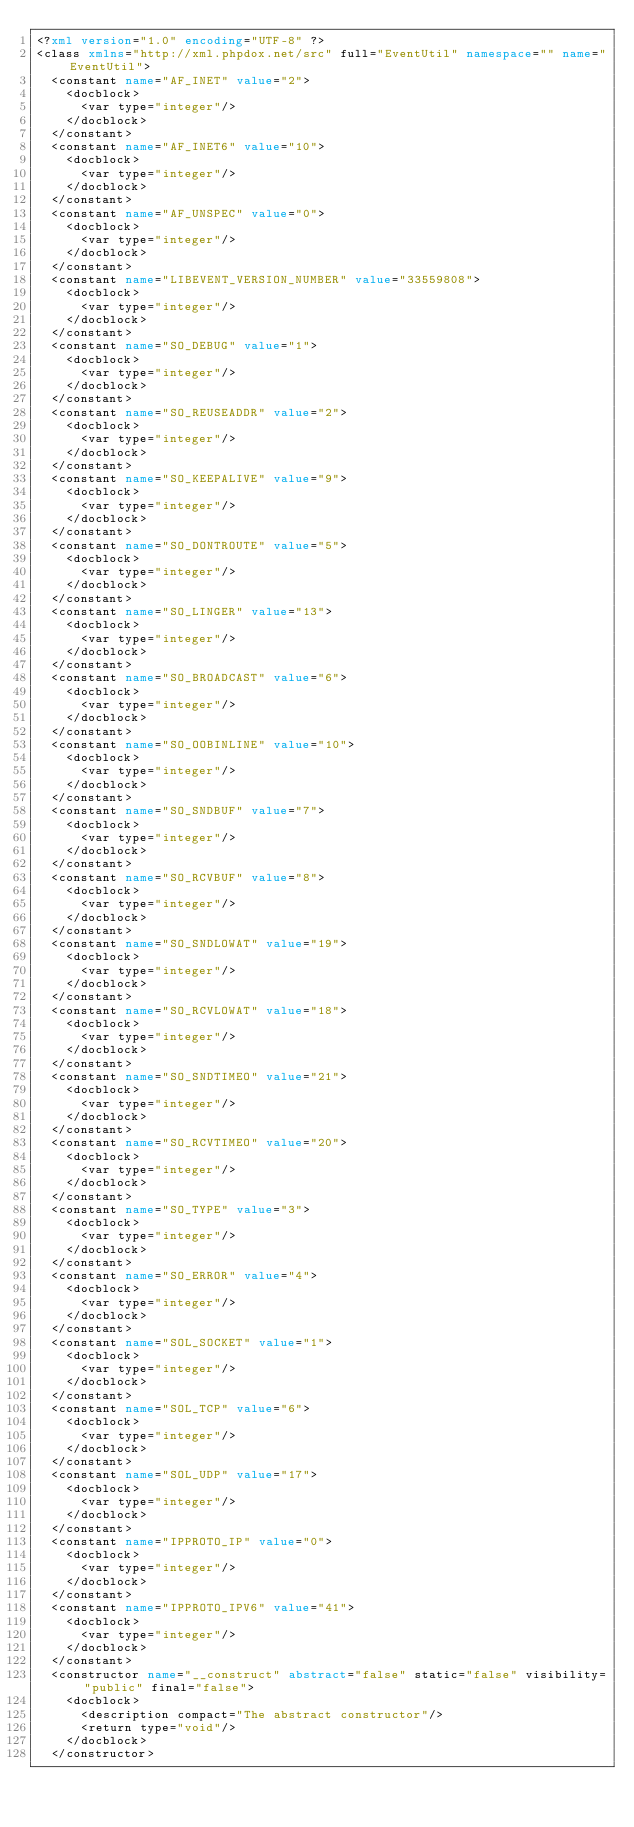Convert code to text. <code><loc_0><loc_0><loc_500><loc_500><_XML_><?xml version="1.0" encoding="UTF-8" ?>
<class xmlns="http://xml.phpdox.net/src" full="EventUtil" namespace="" name="EventUtil">
  <constant name="AF_INET" value="2">
    <docblock>
      <var type="integer"/>
    </docblock>
  </constant>
  <constant name="AF_INET6" value="10">
    <docblock>
      <var type="integer"/>
    </docblock>
  </constant>
  <constant name="AF_UNSPEC" value="0">
    <docblock>
      <var type="integer"/>
    </docblock>
  </constant>
  <constant name="LIBEVENT_VERSION_NUMBER" value="33559808">
    <docblock>
      <var type="integer"/>
    </docblock>
  </constant>
  <constant name="SO_DEBUG" value="1">
    <docblock>
      <var type="integer"/>
    </docblock>
  </constant>
  <constant name="SO_REUSEADDR" value="2">
    <docblock>
      <var type="integer"/>
    </docblock>
  </constant>
  <constant name="SO_KEEPALIVE" value="9">
    <docblock>
      <var type="integer"/>
    </docblock>
  </constant>
  <constant name="SO_DONTROUTE" value="5">
    <docblock>
      <var type="integer"/>
    </docblock>
  </constant>
  <constant name="SO_LINGER" value="13">
    <docblock>
      <var type="integer"/>
    </docblock>
  </constant>
  <constant name="SO_BROADCAST" value="6">
    <docblock>
      <var type="integer"/>
    </docblock>
  </constant>
  <constant name="SO_OOBINLINE" value="10">
    <docblock>
      <var type="integer"/>
    </docblock>
  </constant>
  <constant name="SO_SNDBUF" value="7">
    <docblock>
      <var type="integer"/>
    </docblock>
  </constant>
  <constant name="SO_RCVBUF" value="8">
    <docblock>
      <var type="integer"/>
    </docblock>
  </constant>
  <constant name="SO_SNDLOWAT" value="19">
    <docblock>
      <var type="integer"/>
    </docblock>
  </constant>
  <constant name="SO_RCVLOWAT" value="18">
    <docblock>
      <var type="integer"/>
    </docblock>
  </constant>
  <constant name="SO_SNDTIMEO" value="21">
    <docblock>
      <var type="integer"/>
    </docblock>
  </constant>
  <constant name="SO_RCVTIMEO" value="20">
    <docblock>
      <var type="integer"/>
    </docblock>
  </constant>
  <constant name="SO_TYPE" value="3">
    <docblock>
      <var type="integer"/>
    </docblock>
  </constant>
  <constant name="SO_ERROR" value="4">
    <docblock>
      <var type="integer"/>
    </docblock>
  </constant>
  <constant name="SOL_SOCKET" value="1">
    <docblock>
      <var type="integer"/>
    </docblock>
  </constant>
  <constant name="SOL_TCP" value="6">
    <docblock>
      <var type="integer"/>
    </docblock>
  </constant>
  <constant name="SOL_UDP" value="17">
    <docblock>
      <var type="integer"/>
    </docblock>
  </constant>
  <constant name="IPPROTO_IP" value="0">
    <docblock>
      <var type="integer"/>
    </docblock>
  </constant>
  <constant name="IPPROTO_IPV6" value="41">
    <docblock>
      <var type="integer"/>
    </docblock>
  </constant>
  <constructor name="__construct" abstract="false" static="false" visibility="public" final="false">
    <docblock>
      <description compact="The abstract constructor"/>
      <return type="void"/>
    </docblock>
  </constructor></code> 